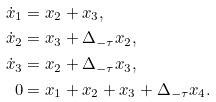<formula> <loc_0><loc_0><loc_500><loc_500>\dot { x } _ { 1 } & = x _ { 2 } + x _ { 3 } , \\ \dot { x } _ { 2 } & = x _ { 3 } + \Delta _ { - \tau } x _ { 2 } , \\ \dot { x } _ { 3 } & = x _ { 2 } + \Delta _ { - \tau } x _ { 3 } , \\ 0 & = x _ { 1 } + x _ { 2 } + x _ { 3 } + \Delta _ { - \tau } x _ { 4 } .</formula> 